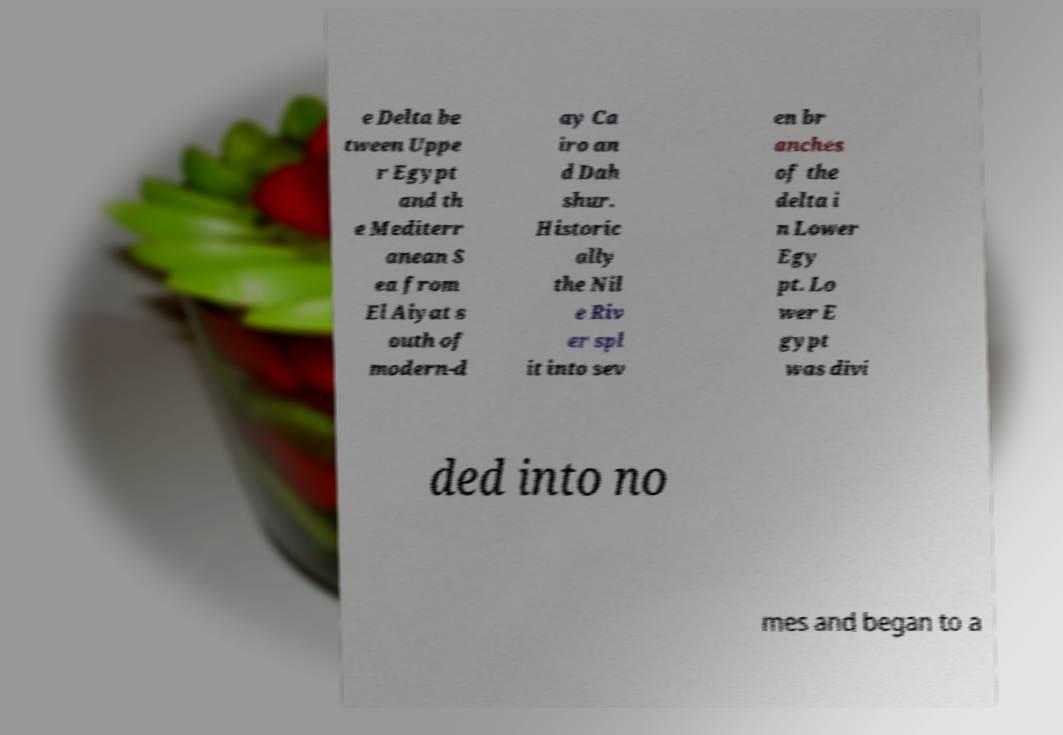I need the written content from this picture converted into text. Can you do that? e Delta be tween Uppe r Egypt and th e Mediterr anean S ea from El Aiyat s outh of modern-d ay Ca iro an d Dah shur. Historic ally the Nil e Riv er spl it into sev en br anches of the delta i n Lower Egy pt. Lo wer E gypt was divi ded into no mes and began to a 